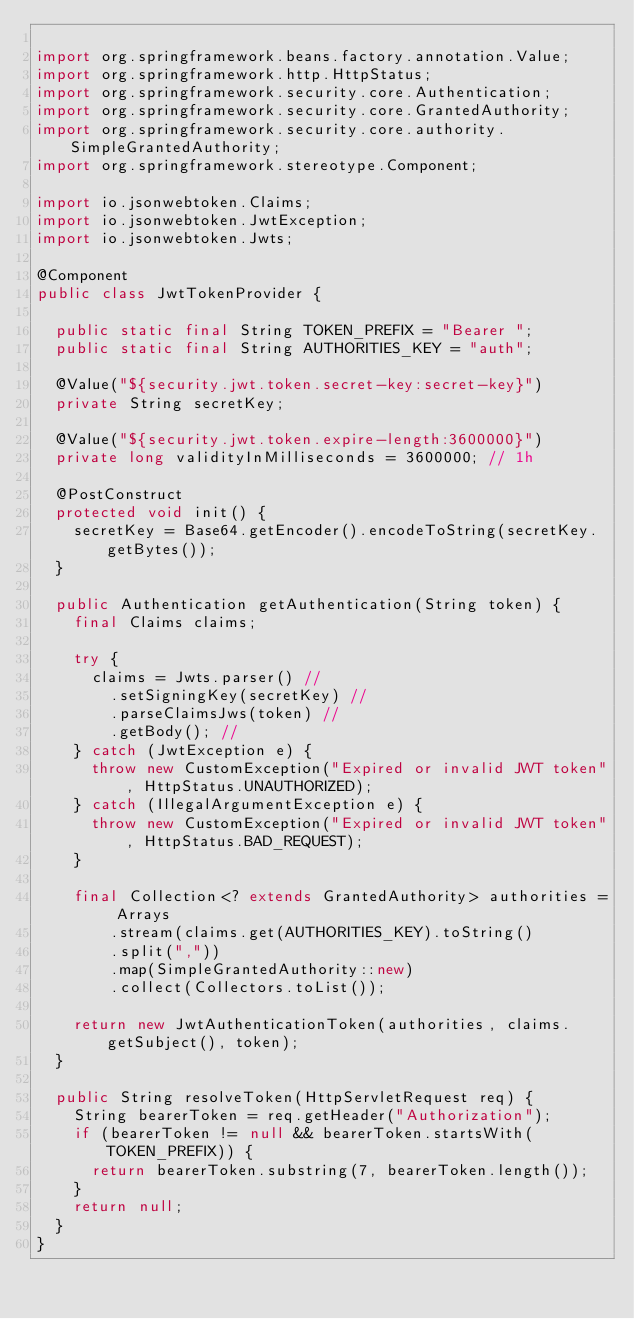Convert code to text. <code><loc_0><loc_0><loc_500><loc_500><_Java_>
import org.springframework.beans.factory.annotation.Value;
import org.springframework.http.HttpStatus;
import org.springframework.security.core.Authentication;
import org.springframework.security.core.GrantedAuthority;
import org.springframework.security.core.authority.SimpleGrantedAuthority;
import org.springframework.stereotype.Component;

import io.jsonwebtoken.Claims;
import io.jsonwebtoken.JwtException;
import io.jsonwebtoken.Jwts;

@Component
public class JwtTokenProvider {

	public static final String TOKEN_PREFIX = "Bearer ";
	public static final String AUTHORITIES_KEY = "auth";

	@Value("${security.jwt.token.secret-key:secret-key}")
	private String secretKey;

	@Value("${security.jwt.token.expire-length:3600000}")
	private long validityInMilliseconds = 3600000; // 1h

	@PostConstruct
	protected void init() {
		secretKey = Base64.getEncoder().encodeToString(secretKey.getBytes());
	}

	public Authentication getAuthentication(String token) {
		final Claims claims;
		
		try {
			claims = Jwts.parser() //
				.setSigningKey(secretKey) //
				.parseClaimsJws(token) //
				.getBody(); //
		} catch (JwtException e) {
			throw new CustomException("Expired or invalid JWT token", HttpStatus.UNAUTHORIZED);
		} catch (IllegalArgumentException e) {
			throw new CustomException("Expired or invalid JWT token", HttpStatus.BAD_REQUEST);
		}

		final Collection<? extends GrantedAuthority> authorities = Arrays
				.stream(claims.get(AUTHORITIES_KEY).toString()
				.split(","))
				.map(SimpleGrantedAuthority::new)
				.collect(Collectors.toList());

		return new JwtAuthenticationToken(authorities, claims.getSubject(), token);
	}

	public String resolveToken(HttpServletRequest req) {
		String bearerToken = req.getHeader("Authorization");
		if (bearerToken != null && bearerToken.startsWith(TOKEN_PREFIX)) {
			return bearerToken.substring(7, bearerToken.length());
		}
		return null;
	}
}
</code> 